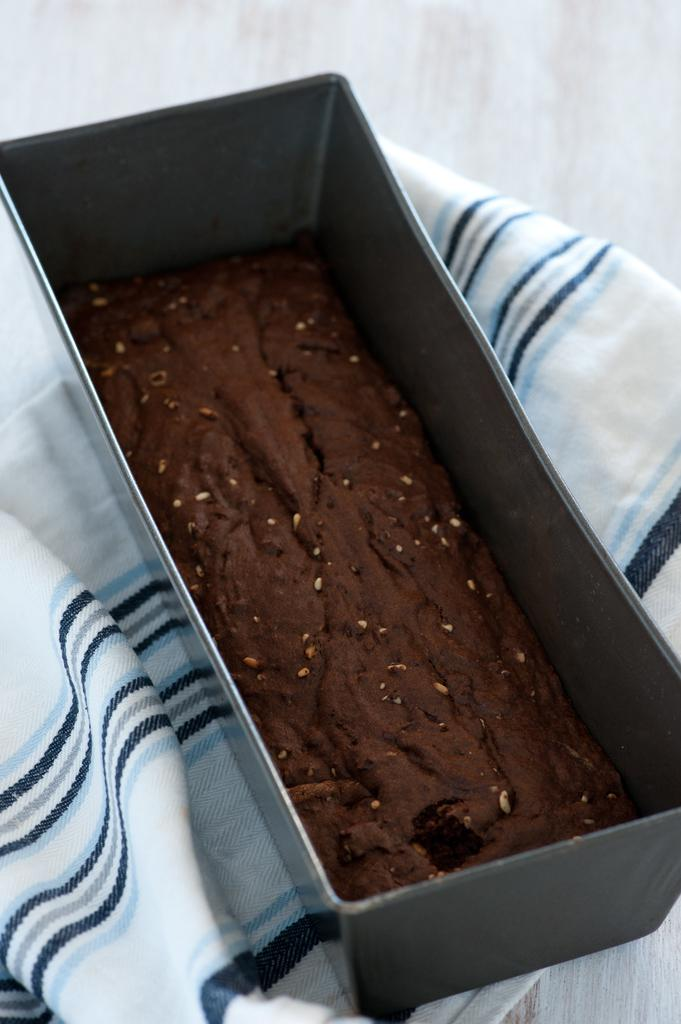What is on the tray that is visible in the image? There is a tray with cake in the image. What is the tray placed on? The tray is on a white and blue color cloth. What can be seen in the background of the image? There is a wall in the background of the image. How does the wind affect the cake on the tray in the image? There is no wind present in the image, so it cannot affect the cake on the tray. 